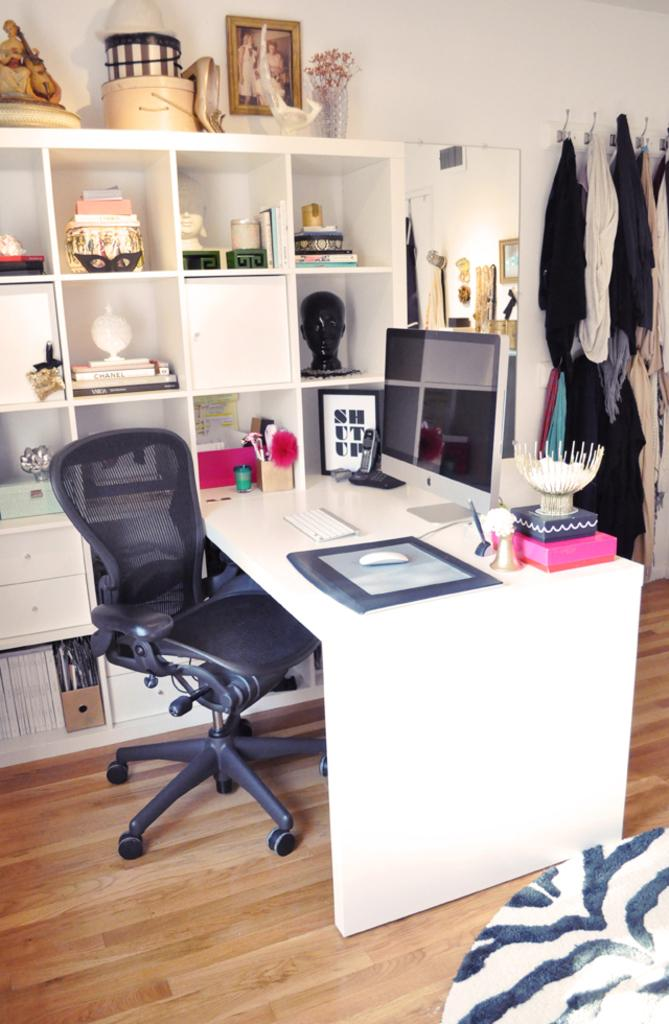<image>
Offer a succinct explanation of the picture presented. a white desk and bookcase with a framed picture that says shut up in black and white. 